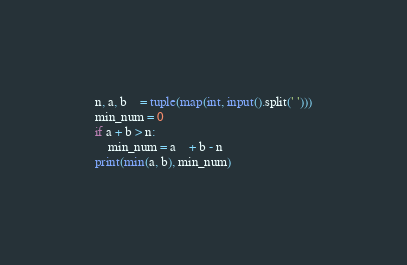Convert code to text. <code><loc_0><loc_0><loc_500><loc_500><_Python_>n, a, b	= tuple(map(int, input().split(' ')))
min_num = 0
if a + b > n:
    min_num = a	+ b - n
print(min(a, b), min_num)</code> 